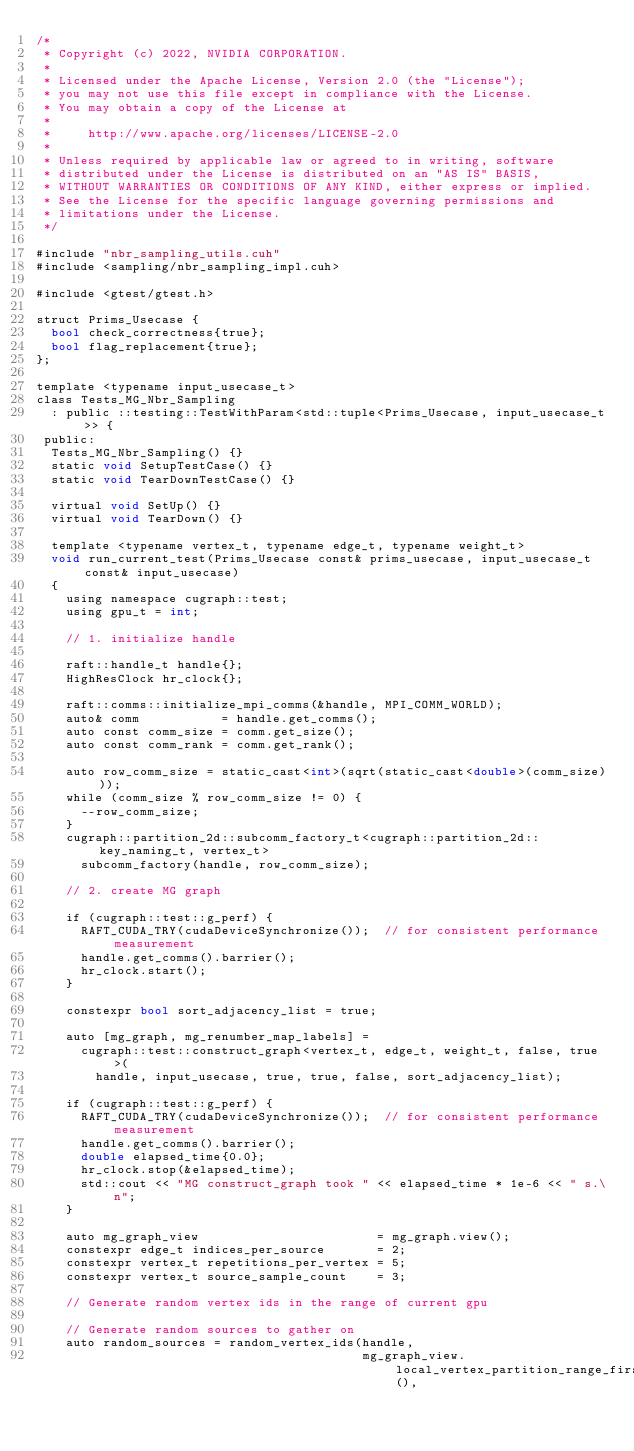<code> <loc_0><loc_0><loc_500><loc_500><_Cuda_>/*
 * Copyright (c) 2022, NVIDIA CORPORATION.
 *
 * Licensed under the Apache License, Version 2.0 (the "License");
 * you may not use this file except in compliance with the License.
 * You may obtain a copy of the License at
 *
 *     http://www.apache.org/licenses/LICENSE-2.0
 *
 * Unless required by applicable law or agreed to in writing, software
 * distributed under the License is distributed on an "AS IS" BASIS,
 * WITHOUT WARRANTIES OR CONDITIONS OF ANY KIND, either express or implied.
 * See the License for the specific language governing permissions and
 * limitations under the License.
 */

#include "nbr_sampling_utils.cuh"
#include <sampling/nbr_sampling_impl.cuh>

#include <gtest/gtest.h>

struct Prims_Usecase {
  bool check_correctness{true};
  bool flag_replacement{true};
};

template <typename input_usecase_t>
class Tests_MG_Nbr_Sampling
  : public ::testing::TestWithParam<std::tuple<Prims_Usecase, input_usecase_t>> {
 public:
  Tests_MG_Nbr_Sampling() {}
  static void SetupTestCase() {}
  static void TearDownTestCase() {}

  virtual void SetUp() {}
  virtual void TearDown() {}

  template <typename vertex_t, typename edge_t, typename weight_t>
  void run_current_test(Prims_Usecase const& prims_usecase, input_usecase_t const& input_usecase)
  {
    using namespace cugraph::test;
    using gpu_t = int;

    // 1. initialize handle

    raft::handle_t handle{};
    HighResClock hr_clock{};

    raft::comms::initialize_mpi_comms(&handle, MPI_COMM_WORLD);
    auto& comm           = handle.get_comms();
    auto const comm_size = comm.get_size();
    auto const comm_rank = comm.get_rank();

    auto row_comm_size = static_cast<int>(sqrt(static_cast<double>(comm_size)));
    while (comm_size % row_comm_size != 0) {
      --row_comm_size;
    }
    cugraph::partition_2d::subcomm_factory_t<cugraph::partition_2d::key_naming_t, vertex_t>
      subcomm_factory(handle, row_comm_size);

    // 2. create MG graph

    if (cugraph::test::g_perf) {
      RAFT_CUDA_TRY(cudaDeviceSynchronize());  // for consistent performance measurement
      handle.get_comms().barrier();
      hr_clock.start();
    }

    constexpr bool sort_adjacency_list = true;

    auto [mg_graph, mg_renumber_map_labels] =
      cugraph::test::construct_graph<vertex_t, edge_t, weight_t, false, true>(
        handle, input_usecase, true, true, false, sort_adjacency_list);

    if (cugraph::test::g_perf) {
      RAFT_CUDA_TRY(cudaDeviceSynchronize());  // for consistent performance measurement
      handle.get_comms().barrier();
      double elapsed_time{0.0};
      hr_clock.stop(&elapsed_time);
      std::cout << "MG construct_graph took " << elapsed_time * 1e-6 << " s.\n";
    }

    auto mg_graph_view                        = mg_graph.view();
    constexpr edge_t indices_per_source       = 2;
    constexpr vertex_t repetitions_per_vertex = 5;
    constexpr vertex_t source_sample_count    = 3;

    // Generate random vertex ids in the range of current gpu

    // Generate random sources to gather on
    auto random_sources = random_vertex_ids(handle,
                                            mg_graph_view.local_vertex_partition_range_first(),</code> 